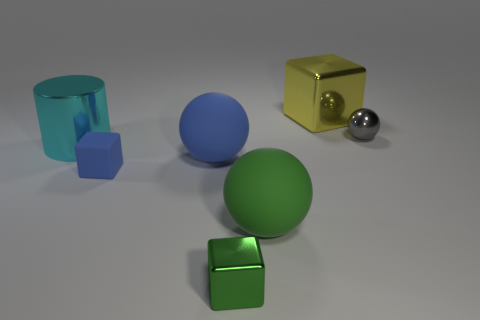How many objects are small red balls or tiny green cubes?
Make the answer very short. 1. There is a object that is behind the tiny gray shiny thing that is behind the large cyan shiny cylinder; what number of big yellow metallic blocks are to the left of it?
Provide a short and direct response. 0. Is there anything else that has the same color as the large metal cube?
Provide a succinct answer. No. There is a sphere in front of the tiny blue cube; is its color the same as the metallic object on the left side of the tiny blue cube?
Ensure brevity in your answer.  No. Are there more green matte spheres that are behind the big green thing than tiny green metal blocks behind the blue cube?
Your answer should be very brief. No. What is the material of the big green thing?
Your answer should be very brief. Rubber. The small thing that is behind the big metal thing to the left of the metallic block that is behind the big metallic cylinder is what shape?
Your answer should be compact. Sphere. How many other things are there of the same material as the big cube?
Make the answer very short. 3. Do the sphere behind the cyan metal cylinder and the big object that is to the left of the small rubber block have the same material?
Make the answer very short. Yes. How many metallic things are to the right of the large blue matte object and in front of the large yellow object?
Provide a succinct answer. 2. 